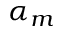<formula> <loc_0><loc_0><loc_500><loc_500>\alpha _ { m }</formula> 